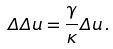Convert formula to latex. <formula><loc_0><loc_0><loc_500><loc_500>\Delta \Delta u = \frac { \gamma } { \kappa } \Delta u \, .</formula> 